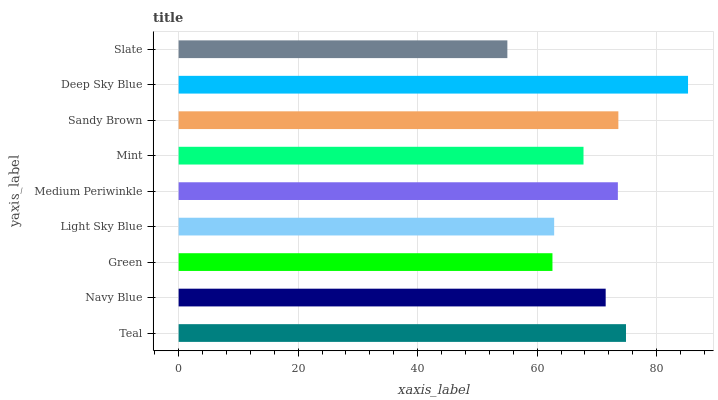Is Slate the minimum?
Answer yes or no. Yes. Is Deep Sky Blue the maximum?
Answer yes or no. Yes. Is Navy Blue the minimum?
Answer yes or no. No. Is Navy Blue the maximum?
Answer yes or no. No. Is Teal greater than Navy Blue?
Answer yes or no. Yes. Is Navy Blue less than Teal?
Answer yes or no. Yes. Is Navy Blue greater than Teal?
Answer yes or no. No. Is Teal less than Navy Blue?
Answer yes or no. No. Is Navy Blue the high median?
Answer yes or no. Yes. Is Navy Blue the low median?
Answer yes or no. Yes. Is Sandy Brown the high median?
Answer yes or no. No. Is Medium Periwinkle the low median?
Answer yes or no. No. 